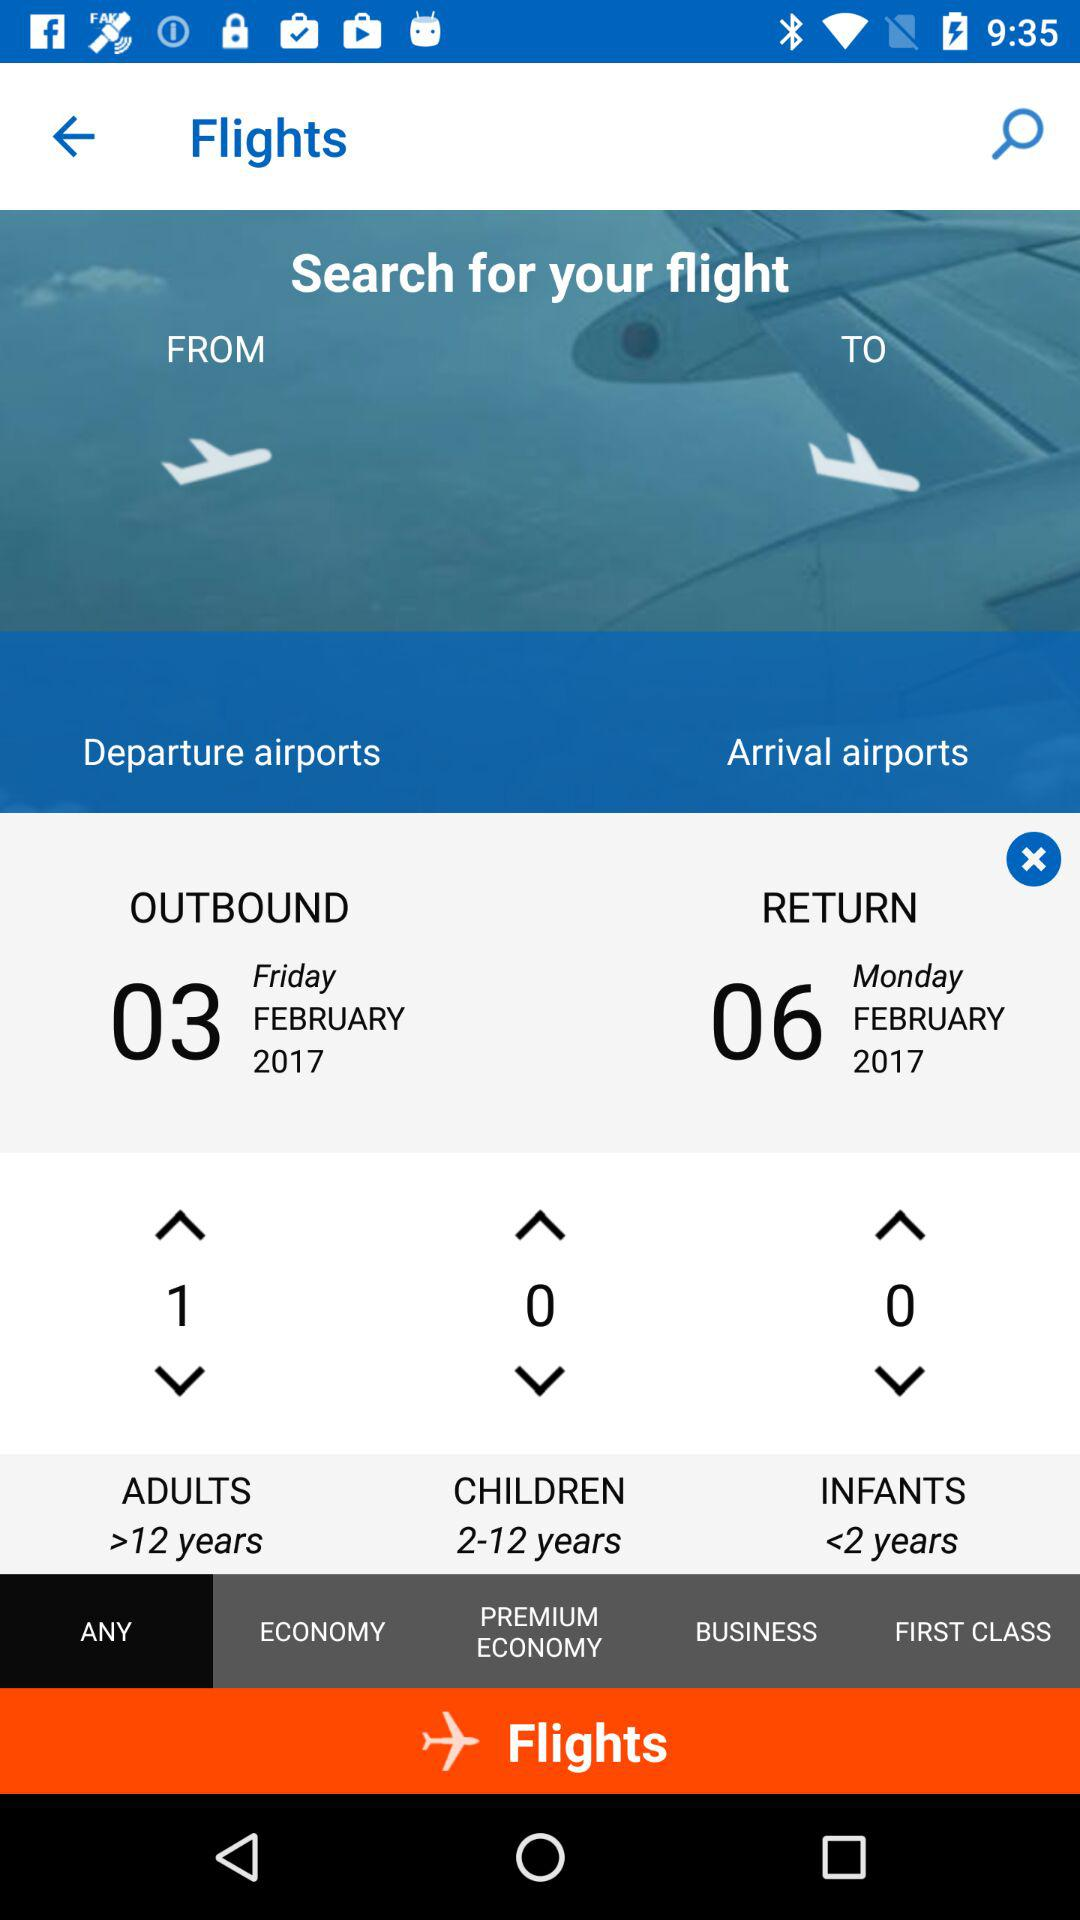How many adults are there? There is 1 adult. 